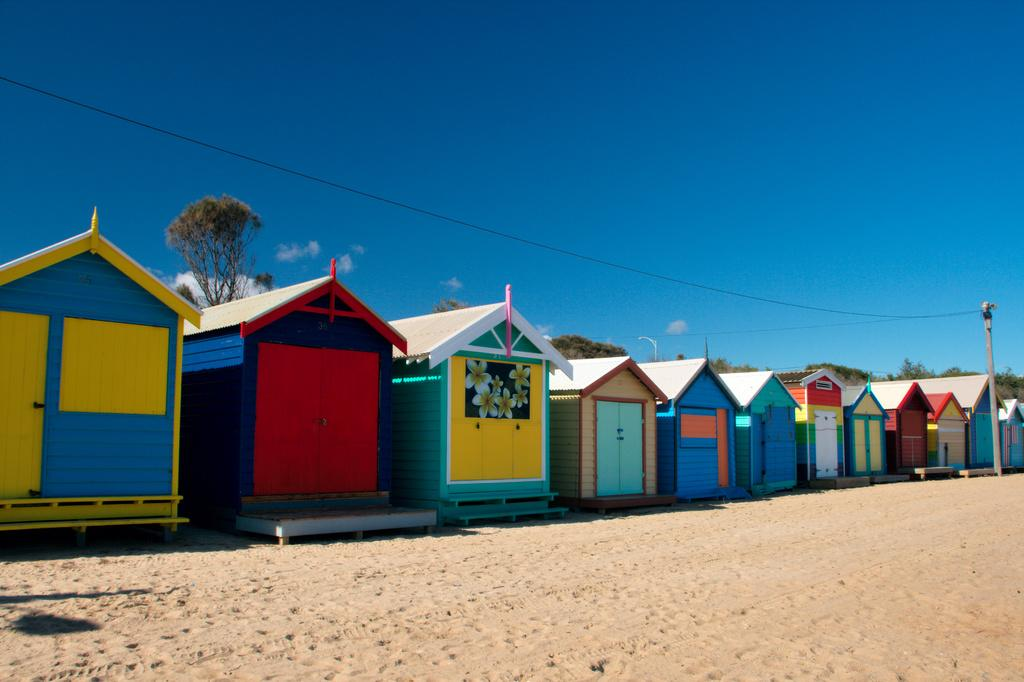What type of structures are present in the image? There are sheds with doors in the image. What type of terrain can be seen in the image? There is sand visible in the image. What object is present in the image that might be used for support or attachment? There is a pole in the image. What type of vegetation is present in the image? There are trees in the image. What can be seen in the background of the image? The sky with clouds is visible in the background of the image. What type of badge can be seen on the trees in the image? There are no badges present on the trees in the image. What type of mountain can be seen in the background of the image? There are no mountains visible in the background of the image; it features the sky with clouds. 